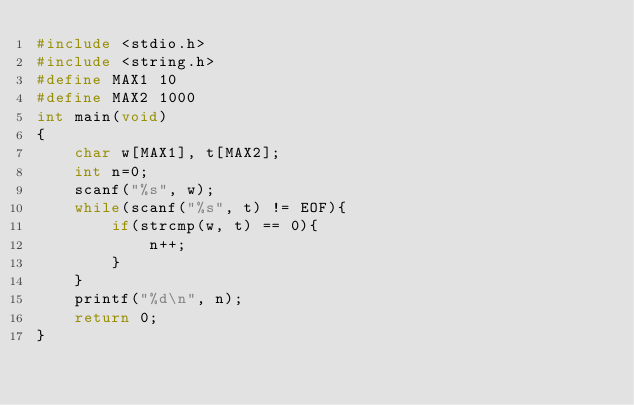Convert code to text. <code><loc_0><loc_0><loc_500><loc_500><_C_>#include <stdio.h>
#include <string.h>
#define MAX1 10
#define MAX2 1000
int main(void)
{
	char w[MAX1], t[MAX2]; 
	int n=0;
	scanf("%s", w);
	while(scanf("%s", t) != EOF){
		if(strcmp(w, t) == 0){
			n++;
		}
	}
	printf("%d\n", n);	
    return 0;
}</code> 